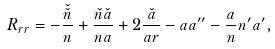Convert formula to latex. <formula><loc_0><loc_0><loc_500><loc_500>R _ { r r } = - \frac { \check { \check { n } } } { n } + \frac { \check { n } \check { a } } { n a } + 2 \frac { \check { a } } { a r } - a a ^ { \prime \prime } - \frac { a } { n } n ^ { \prime } a ^ { \prime } ,</formula> 